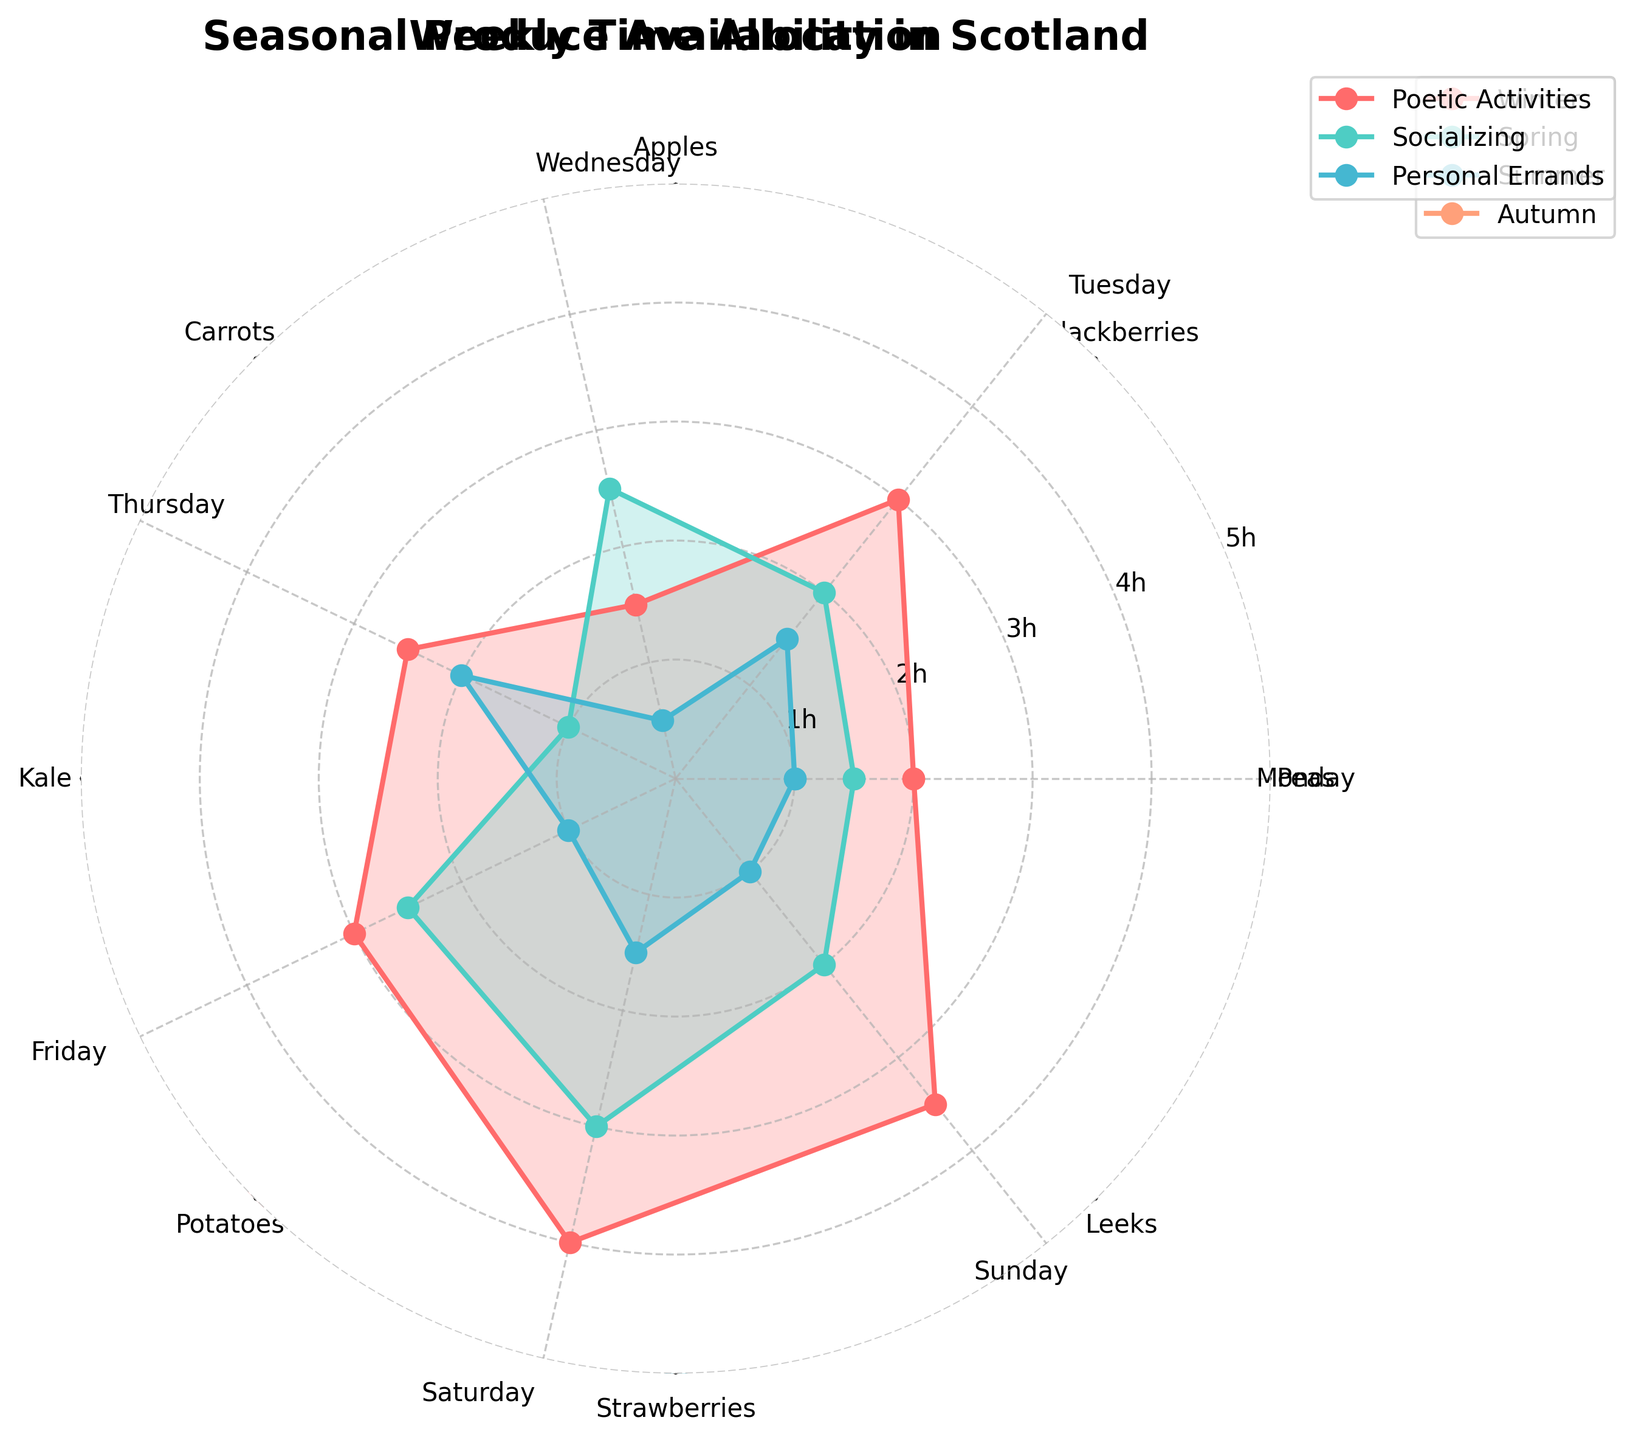What's the title of the figure? The title is usually displayed at the top of the figure. In this case, it is "Weekly Time Allocation".
Answer: Weekly Time Allocation How many categories are plotted on the radar chart? By looking at the labels around the radar chart, you can count the number of categories. In this chart, there are seven categories that correspond to the days of the week.
Answer: 7 Which day has the highest amount of time allocated to Poetic Activities? By comparing the line representing Poetic Activities, you can see that Saturday's plot point is the highest.
Answer: Saturday On which day is the time spent on Socializing greater than the time spent on Personal Errands? Compare the values for Socializing and Personal Errands on each day to find that Tuesday, Wednesday, Friday, and Saturday meet this criterion.
Answer: Tuesday, Wednesday, Friday, Saturday What is the average time spent on Poetic Activities throughout the week? Sum the values for Poetic Activities across the week and then divide by 7: (2 + 3 + 1.5 + 2.5 + 3 + 4 + 3.5)/7 = 2.7857 hours.
Answer: ~2.79 hours Which activity has the most consistent time allocation throughout the week? By observing the spread of the values on the radar chart, Personal Errands appear most consistent as its values range less compared to Poetic Activities and Socializing.
Answer: Personal Errands Are there any days when time allocated to Personal Errands is the same as time allocated to Socializing? Check for overlapping points for Socializing and Personal Errands and see that there are none.
Answer: No On what days is the time spent on Poetic Activities more than three hours? Check the Poetic Activities line to see that Saturday is the only day with more than three hours.
Answer: Saturday Which day shows the least amount of total time allocated across all activities? Sum the total hours allocated on each day and compare: Wednesday has (1.5 + 2.5 + 0.5) = 4.5 hours, which is the lowest.
Answer: Wednesday What is the difference in time spent on Socializing between Friday and Monday? Look at the Socializing times for Friday (2.5) and Monday (1.5) and subtract to find 2.5 - 1.5 = 1 hour.
Answer: 1 hour 